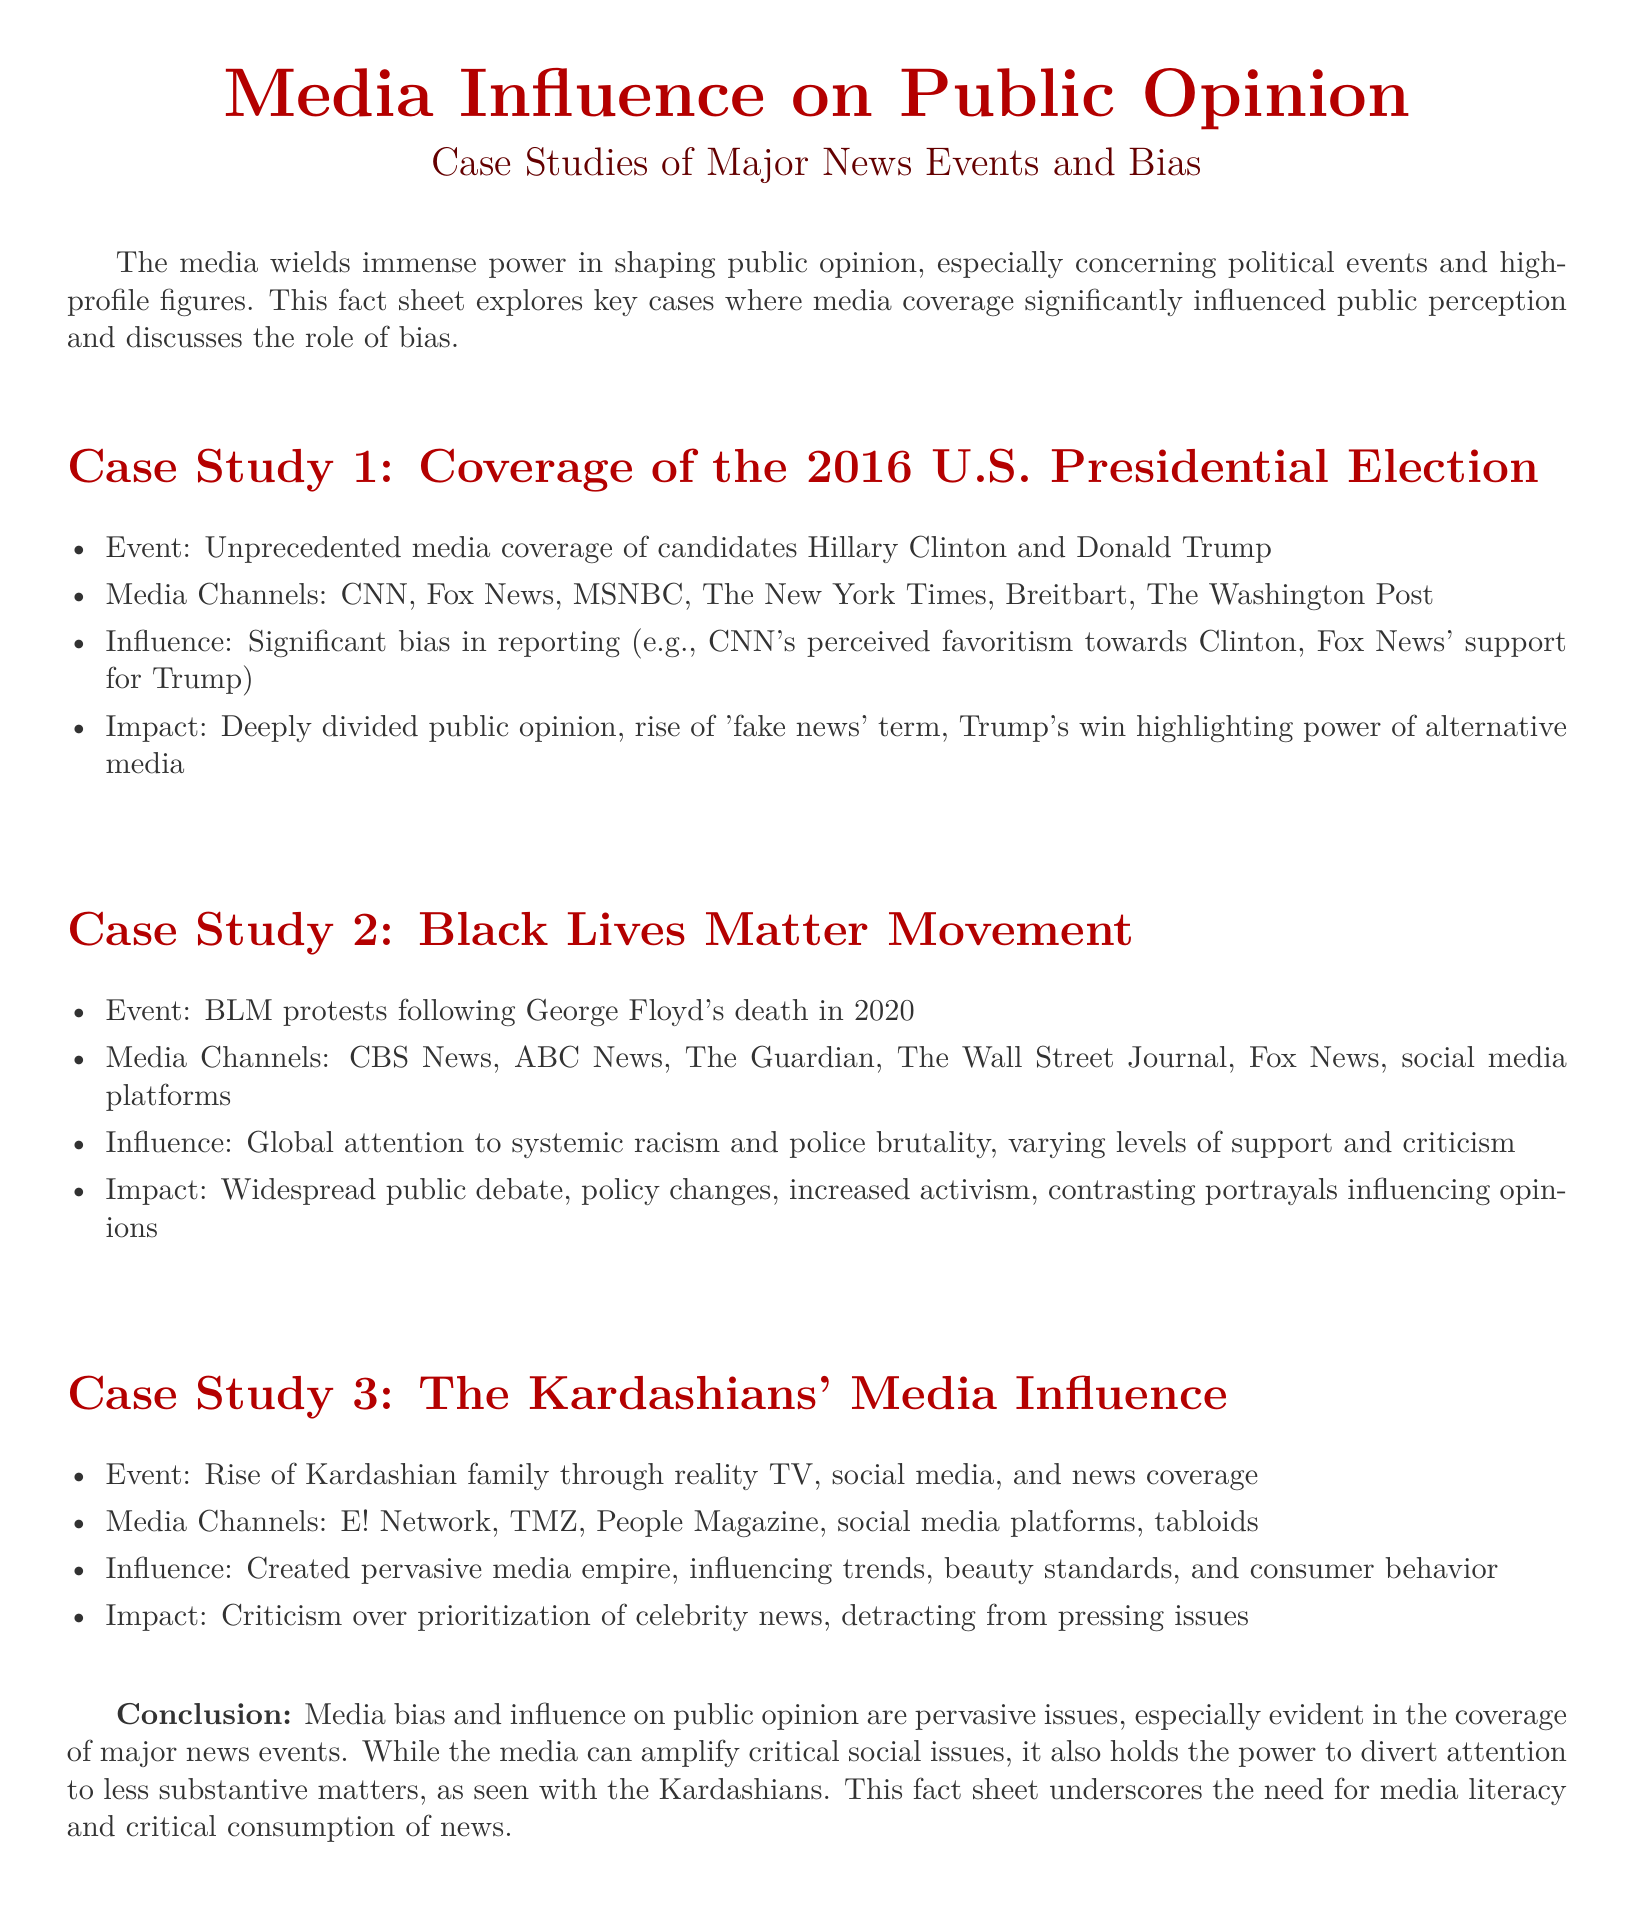What was the event associated with Case Study 1? Case Study 1 discusses the media coverage of the 2016 U.S. Presidential Election.
Answer: 2016 U.S. Presidential Election Which media channel is mentioned in Case Study 2? Case Study 2 lists several media channels, including CBS News, in the context of BLM protests.
Answer: CBS News What was the influence of the Kardashian family's media coverage? The document states that the Kardashians created a pervasive media empire and influenced trends and consumer behavior.
Answer: Pervasive media empire What impact did the Black Lives Matter movement have? The document notes that BLM protests led to widespread public debate and policy changes.
Answer: Widespread public debate What term rose significantly due to the 2016 election coverage? The coverage of the election brought significant attention to the concept of fake news.
Answer: Fake news Which year did George Floyd's death occur? The document specifically notes the year of the protests that followed his death in Case Study 2.
Answer: 2020 What role did social media play in the Kardashian case? The Kardashians used various media channels for their rise, including social media platforms.
Answer: Social media platforms What is a concern raised in the conclusion regarding media coverage? The conclusion points out that media could divert attention to less substantive matters, such as celebrity news.
Answer: Detracting from pressing issues 